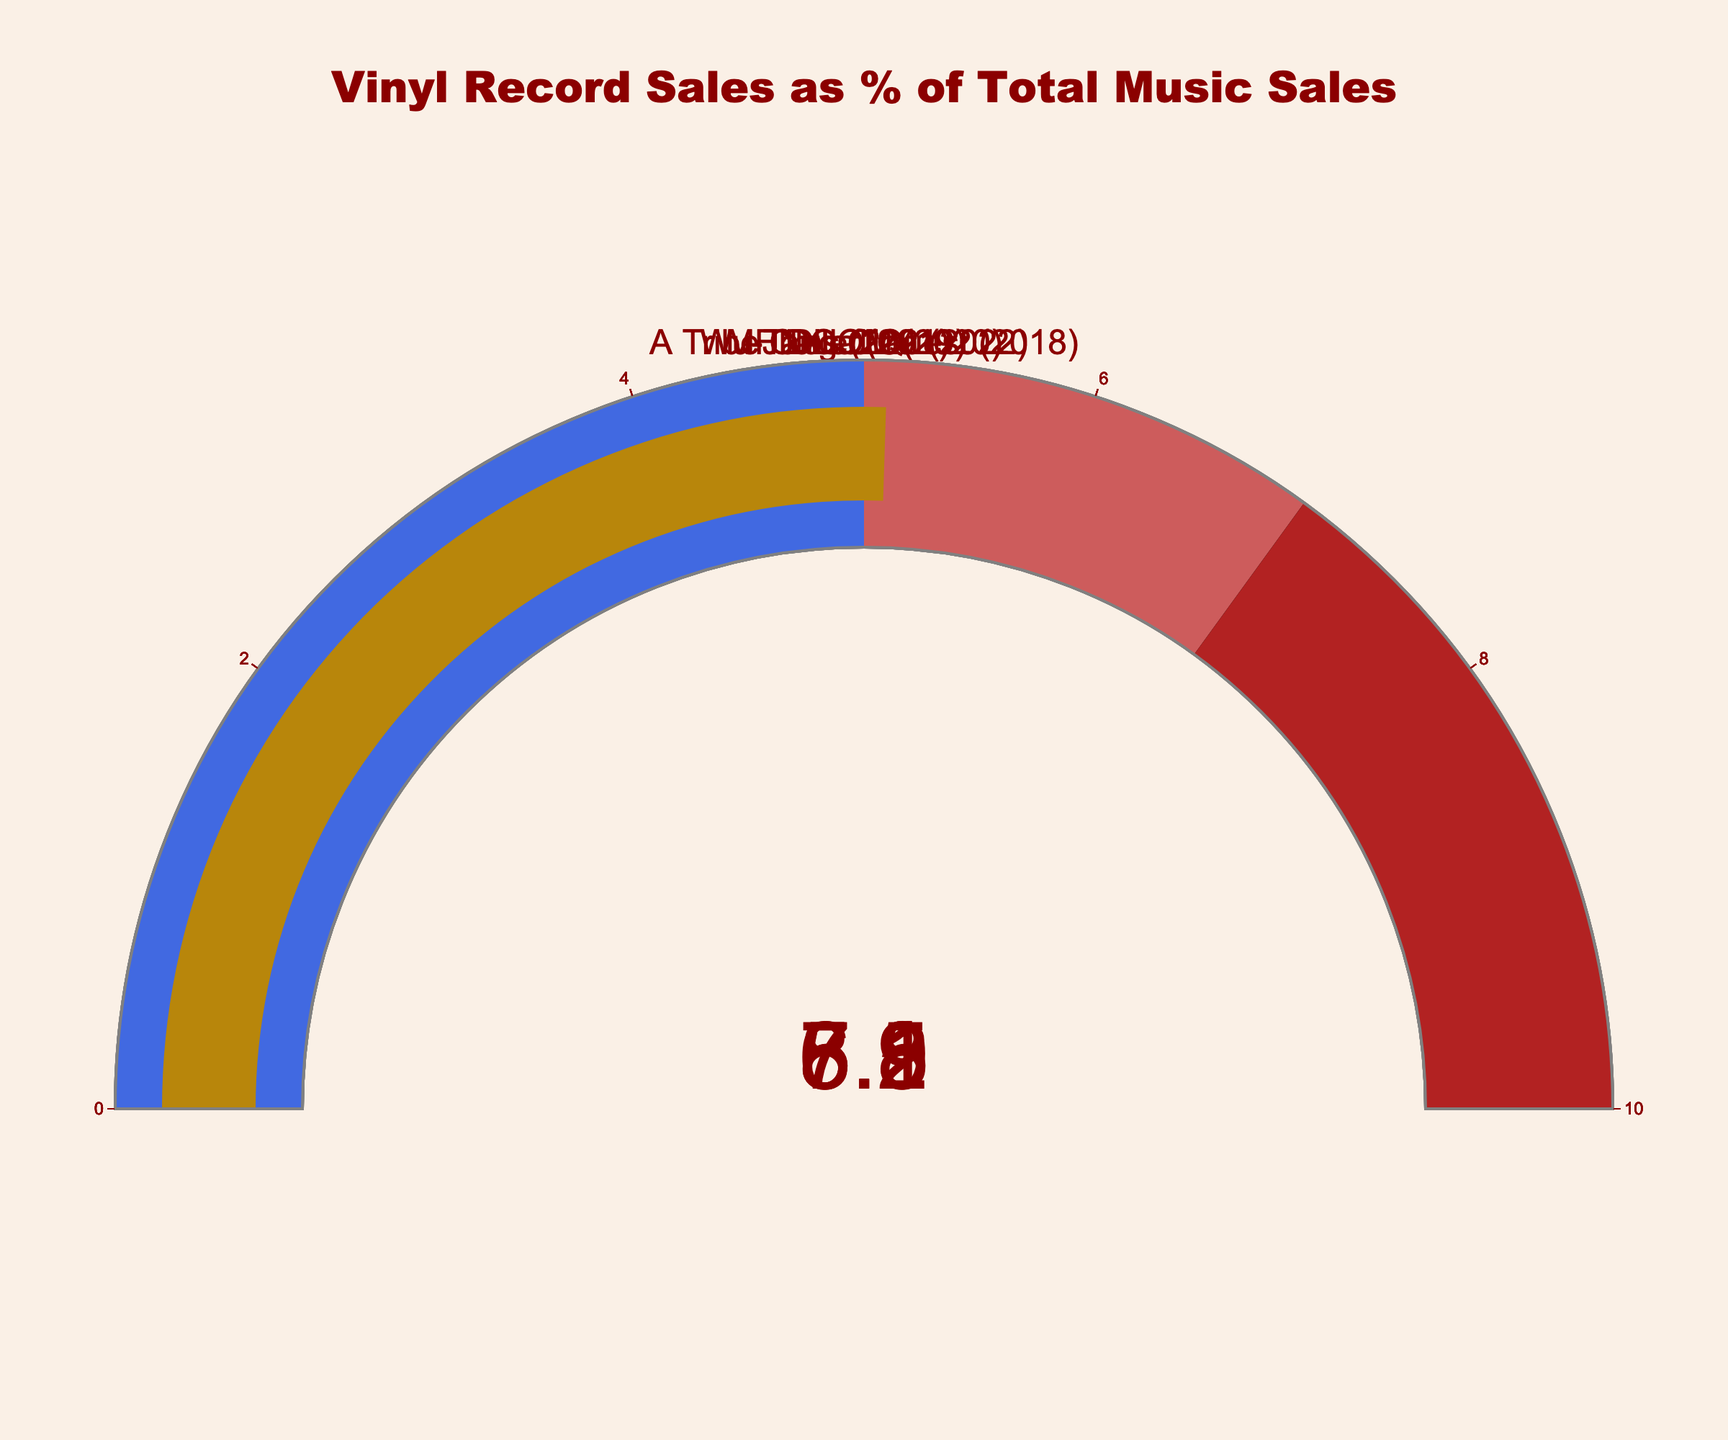What's the title of the figure? The title is displayed at the top of the figure, which is visually prominent in a large font size with a specific color.
Answer: Vinyl Record Sales as % of Total Music Sales How many artists are represented in the figure? By counting the number of gauge charts, each for a different artist, we can determine the total number.
Answer: 5 Which artist has the highest vinyl percentage? By comparing the values on each gauge chart, the artist with the highest percentage can be identified.
Answer: Wu-Tang Clan What's the range of the gauge on the figure? The range can be observed by looking at the axis of the gauge, which shows the minimum and maximum values.
Answer: 0 to 10 Which year's data shows a vinyl percentage of 7.2? By examining the labels associated with the gauge percentages, we find which year contains the value 7.2.
Answer: 2021 What's the difference between the highest and lowest vinyl percentages? Identify the highest and lowest values from the gauge charts, and then subtract the lowest from the highest. The highest is 8.5 (Wu-Tang Clan, 2022) and the lowest is 5.1 (A Tribe Called Quest, 2018). The difference is 8.5 - 5.1.
Answer: 3.4 What's the average vinyl percentage presented in the figure? Sum all vinyl percentages and divide by the number of data points. So, (8.5 + 7.2 + 6.8 + 5.9 + 5.1) / 5 = 33.5 / 5 = 6.7.
Answer: 6.7 Which years have vinyl sales percentages greater than 7%? Check the gauge charts to identify all years where the percentage exceeds 7%. The years are 2022 with 8.5% and 2021 with 7.2%.
Answer: 2022, 2021 Which color represents the gauge section corresponding to vinyl percentages between 5 and 7? Observe the middle section of the gauge in the figure, which highlights the range from 5 to 7.
Answer: Indianred How much did the vinyl percentage increase from J Dilla (2019) to Nas (2021)? Subtract the percentage of J Dilla (5.9) from the percentage of Nas (7.2). The increase is 7.2 - 5.9.
Answer: 1.3 